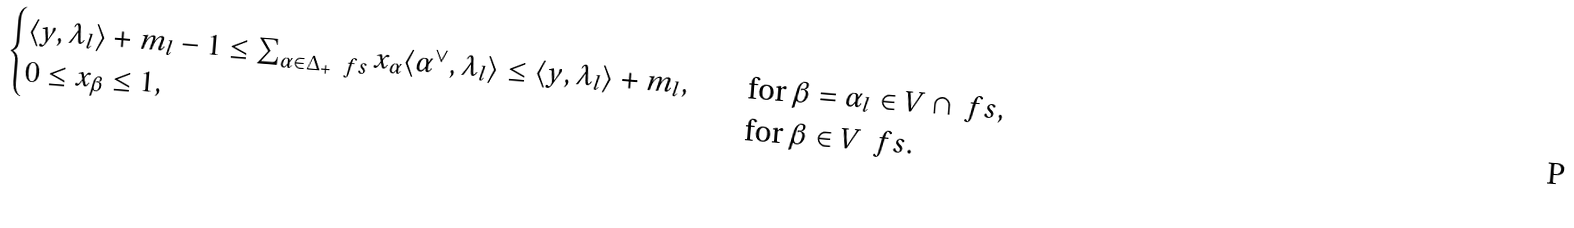<formula> <loc_0><loc_0><loc_500><loc_500>\begin{cases} \langle y , \lambda _ { l } \rangle + m _ { l } - 1 \leq \sum _ { \alpha \in \Delta _ { + } \ \ f s } x _ { \alpha } \langle \alpha ^ { \vee } , \lambda _ { l } \rangle \leq \langle y , \lambda _ { l } \rangle + m _ { l } , \quad & \text {for } \beta = \alpha _ { l } \in V \cap \ f s , \\ 0 \leq x _ { \beta } \leq 1 , \quad & \text {for } \beta \in V \ \ f s . \end{cases}</formula> 